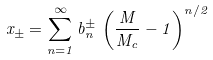Convert formula to latex. <formula><loc_0><loc_0><loc_500><loc_500>x _ { \pm } = \sum _ { n = 1 } ^ { \infty } b ^ { \pm } _ { n } \, \left ( \frac { M } { M _ { c } } - 1 \right ) ^ { n / 2 }</formula> 